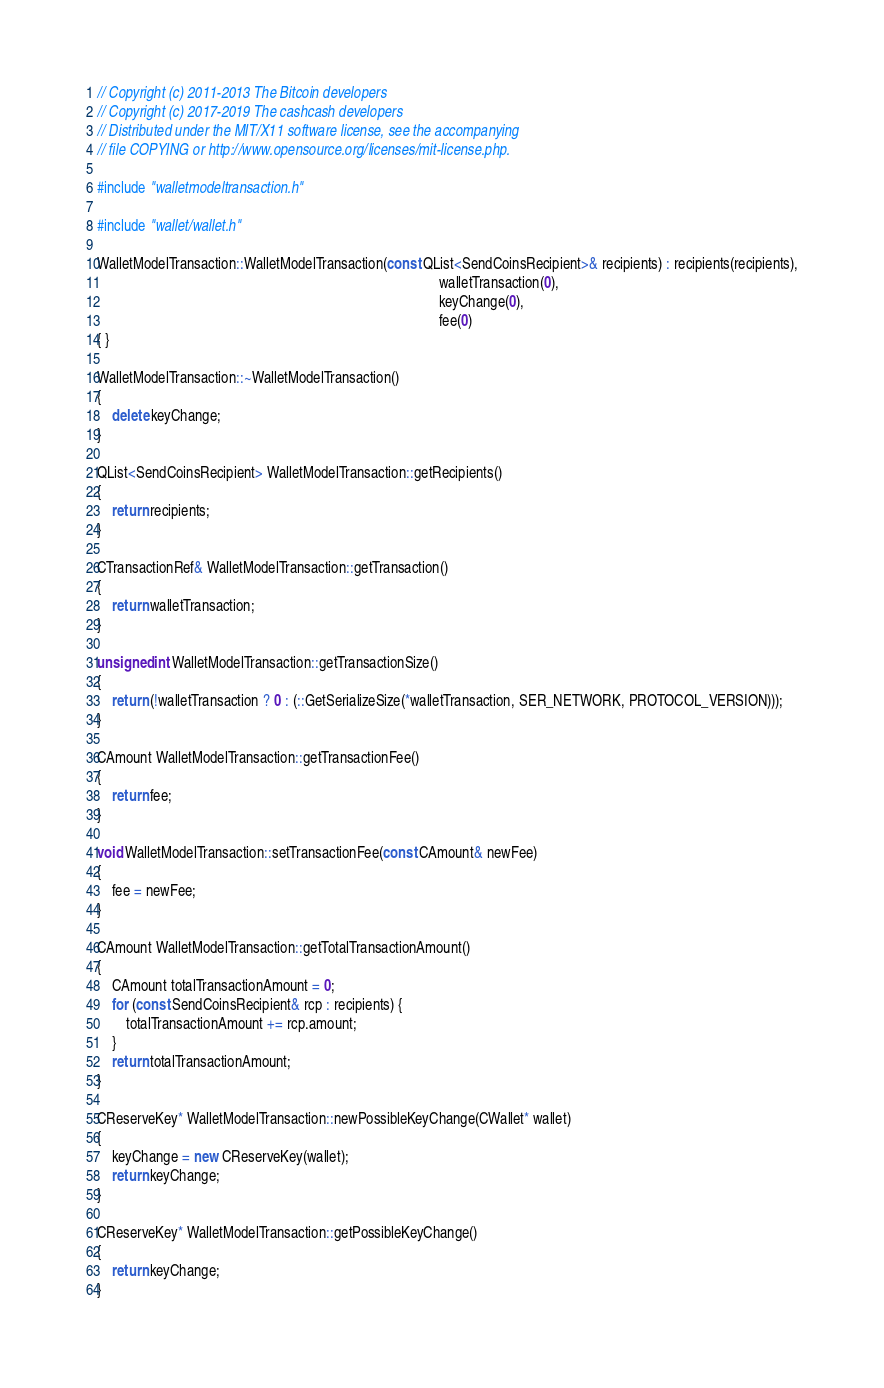<code> <loc_0><loc_0><loc_500><loc_500><_C++_>// Copyright (c) 2011-2013 The Bitcoin developers
// Copyright (c) 2017-2019 The cashcash developers
// Distributed under the MIT/X11 software license, see the accompanying
// file COPYING or http://www.opensource.org/licenses/mit-license.php.

#include "walletmodeltransaction.h"

#include "wallet/wallet.h"

WalletModelTransaction::WalletModelTransaction(const QList<SendCoinsRecipient>& recipients) : recipients(recipients),
                                                                                              walletTransaction(0),
                                                                                              keyChange(0),
                                                                                              fee(0)
{ }

WalletModelTransaction::~WalletModelTransaction()
{
    delete keyChange;
}

QList<SendCoinsRecipient> WalletModelTransaction::getRecipients()
{
    return recipients;
}

CTransactionRef& WalletModelTransaction::getTransaction()
{
    return walletTransaction;
}

unsigned int WalletModelTransaction::getTransactionSize()
{
    return (!walletTransaction ? 0 : (::GetSerializeSize(*walletTransaction, SER_NETWORK, PROTOCOL_VERSION)));
}

CAmount WalletModelTransaction::getTransactionFee()
{
    return fee;
}

void WalletModelTransaction::setTransactionFee(const CAmount& newFee)
{
    fee = newFee;
}

CAmount WalletModelTransaction::getTotalTransactionAmount()
{
    CAmount totalTransactionAmount = 0;
    for (const SendCoinsRecipient& rcp : recipients) {
        totalTransactionAmount += rcp.amount;
    }
    return totalTransactionAmount;
}

CReserveKey* WalletModelTransaction::newPossibleKeyChange(CWallet* wallet)
{
    keyChange = new CReserveKey(wallet);
    return keyChange;
}

CReserveKey* WalletModelTransaction::getPossibleKeyChange()
{
    return keyChange;
}
</code> 